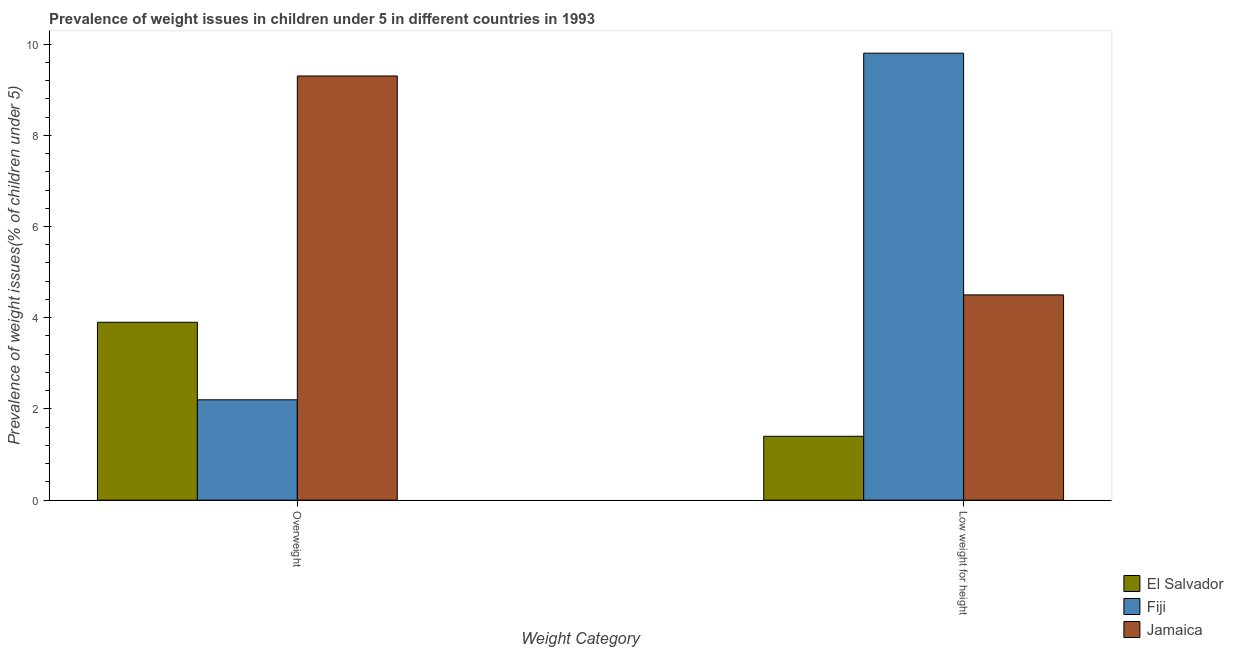Are the number of bars per tick equal to the number of legend labels?
Ensure brevity in your answer.  Yes. How many bars are there on the 1st tick from the left?
Your response must be concise. 3. How many bars are there on the 1st tick from the right?
Make the answer very short. 3. What is the label of the 1st group of bars from the left?
Your response must be concise. Overweight. What is the percentage of overweight children in Fiji?
Provide a short and direct response. 2.2. Across all countries, what is the maximum percentage of overweight children?
Your answer should be compact. 9.3. Across all countries, what is the minimum percentage of overweight children?
Provide a short and direct response. 2.2. In which country was the percentage of overweight children maximum?
Ensure brevity in your answer.  Jamaica. In which country was the percentage of underweight children minimum?
Provide a short and direct response. El Salvador. What is the total percentage of underweight children in the graph?
Offer a terse response. 15.7. What is the difference between the percentage of underweight children in El Salvador and that in Jamaica?
Ensure brevity in your answer.  -3.1. What is the difference between the percentage of underweight children in Fiji and the percentage of overweight children in Jamaica?
Ensure brevity in your answer.  0.5. What is the average percentage of underweight children per country?
Your response must be concise. 5.23. What is the difference between the percentage of overweight children and percentage of underweight children in Fiji?
Provide a short and direct response. -7.6. In how many countries, is the percentage of underweight children greater than 8.8 %?
Make the answer very short. 1. What is the ratio of the percentage of underweight children in El Salvador to that in Jamaica?
Give a very brief answer. 0.31. Is the percentage of overweight children in Jamaica less than that in Fiji?
Provide a succinct answer. No. What does the 3rd bar from the left in Overweight represents?
Your answer should be compact. Jamaica. What does the 2nd bar from the right in Overweight represents?
Your response must be concise. Fiji. How many bars are there?
Make the answer very short. 6. Where does the legend appear in the graph?
Provide a succinct answer. Bottom right. What is the title of the graph?
Your answer should be compact. Prevalence of weight issues in children under 5 in different countries in 1993. Does "St. Martin (French part)" appear as one of the legend labels in the graph?
Your answer should be very brief. No. What is the label or title of the X-axis?
Give a very brief answer. Weight Category. What is the label or title of the Y-axis?
Provide a succinct answer. Prevalence of weight issues(% of children under 5). What is the Prevalence of weight issues(% of children under 5) of El Salvador in Overweight?
Your response must be concise. 3.9. What is the Prevalence of weight issues(% of children under 5) of Fiji in Overweight?
Your answer should be very brief. 2.2. What is the Prevalence of weight issues(% of children under 5) of Jamaica in Overweight?
Keep it short and to the point. 9.3. What is the Prevalence of weight issues(% of children under 5) of El Salvador in Low weight for height?
Offer a very short reply. 1.4. What is the Prevalence of weight issues(% of children under 5) in Fiji in Low weight for height?
Offer a very short reply. 9.8. Across all Weight Category, what is the maximum Prevalence of weight issues(% of children under 5) in El Salvador?
Ensure brevity in your answer.  3.9. Across all Weight Category, what is the maximum Prevalence of weight issues(% of children under 5) in Fiji?
Your answer should be very brief. 9.8. Across all Weight Category, what is the maximum Prevalence of weight issues(% of children under 5) in Jamaica?
Ensure brevity in your answer.  9.3. Across all Weight Category, what is the minimum Prevalence of weight issues(% of children under 5) in El Salvador?
Make the answer very short. 1.4. Across all Weight Category, what is the minimum Prevalence of weight issues(% of children under 5) of Fiji?
Offer a terse response. 2.2. Across all Weight Category, what is the minimum Prevalence of weight issues(% of children under 5) in Jamaica?
Your response must be concise. 4.5. What is the total Prevalence of weight issues(% of children under 5) in El Salvador in the graph?
Make the answer very short. 5.3. What is the difference between the Prevalence of weight issues(% of children under 5) in El Salvador in Overweight and that in Low weight for height?
Give a very brief answer. 2.5. What is the difference between the Prevalence of weight issues(% of children under 5) of Fiji in Overweight and that in Low weight for height?
Your response must be concise. -7.6. What is the difference between the Prevalence of weight issues(% of children under 5) of Jamaica in Overweight and that in Low weight for height?
Offer a very short reply. 4.8. What is the difference between the Prevalence of weight issues(% of children under 5) of El Salvador in Overweight and the Prevalence of weight issues(% of children under 5) of Fiji in Low weight for height?
Your response must be concise. -5.9. What is the difference between the Prevalence of weight issues(% of children under 5) in El Salvador in Overweight and the Prevalence of weight issues(% of children under 5) in Jamaica in Low weight for height?
Your response must be concise. -0.6. What is the difference between the Prevalence of weight issues(% of children under 5) of Fiji in Overweight and the Prevalence of weight issues(% of children under 5) of Jamaica in Low weight for height?
Offer a very short reply. -2.3. What is the average Prevalence of weight issues(% of children under 5) in El Salvador per Weight Category?
Provide a short and direct response. 2.65. What is the average Prevalence of weight issues(% of children under 5) in Fiji per Weight Category?
Keep it short and to the point. 6. What is the difference between the Prevalence of weight issues(% of children under 5) of El Salvador and Prevalence of weight issues(% of children under 5) of Jamaica in Low weight for height?
Your answer should be very brief. -3.1. What is the difference between the Prevalence of weight issues(% of children under 5) of Fiji and Prevalence of weight issues(% of children under 5) of Jamaica in Low weight for height?
Make the answer very short. 5.3. What is the ratio of the Prevalence of weight issues(% of children under 5) of El Salvador in Overweight to that in Low weight for height?
Keep it short and to the point. 2.79. What is the ratio of the Prevalence of weight issues(% of children under 5) in Fiji in Overweight to that in Low weight for height?
Ensure brevity in your answer.  0.22. What is the ratio of the Prevalence of weight issues(% of children under 5) in Jamaica in Overweight to that in Low weight for height?
Your answer should be compact. 2.07. What is the difference between the highest and the second highest Prevalence of weight issues(% of children under 5) of El Salvador?
Your response must be concise. 2.5. What is the difference between the highest and the lowest Prevalence of weight issues(% of children under 5) of Fiji?
Your answer should be compact. 7.6. 